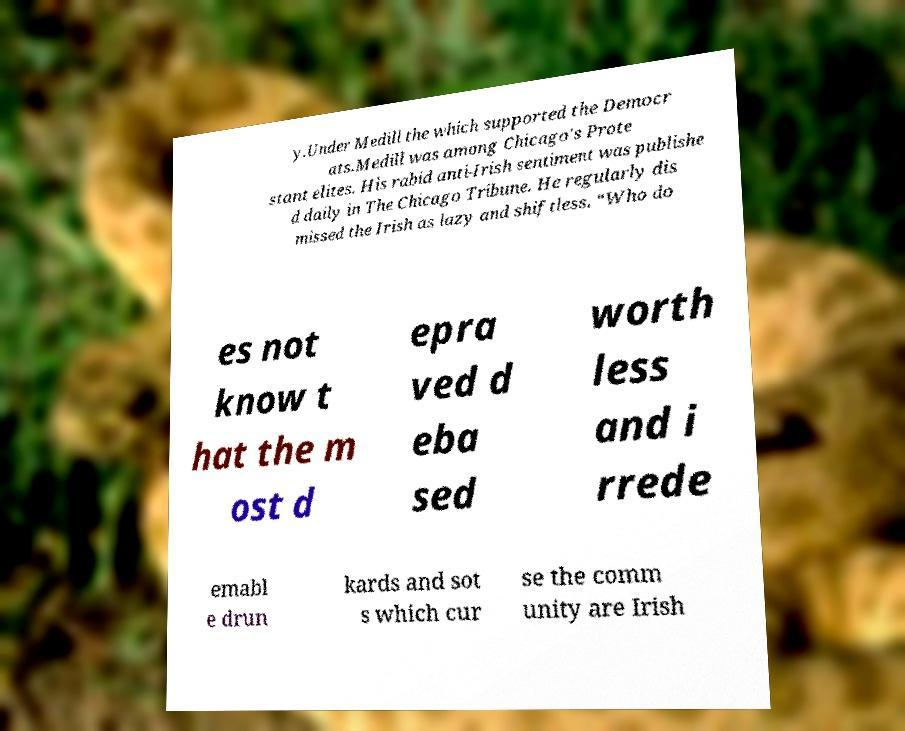Can you accurately transcribe the text from the provided image for me? y.Under Medill the which supported the Democr ats.Medill was among Chicago's Prote stant elites. His rabid anti-Irish sentiment was publishe d daily in The Chicago Tribune. He regularly dis missed the Irish as lazy and shiftless. “Who do es not know t hat the m ost d epra ved d eba sed worth less and i rrede emabl e drun kards and sot s which cur se the comm unity are Irish 